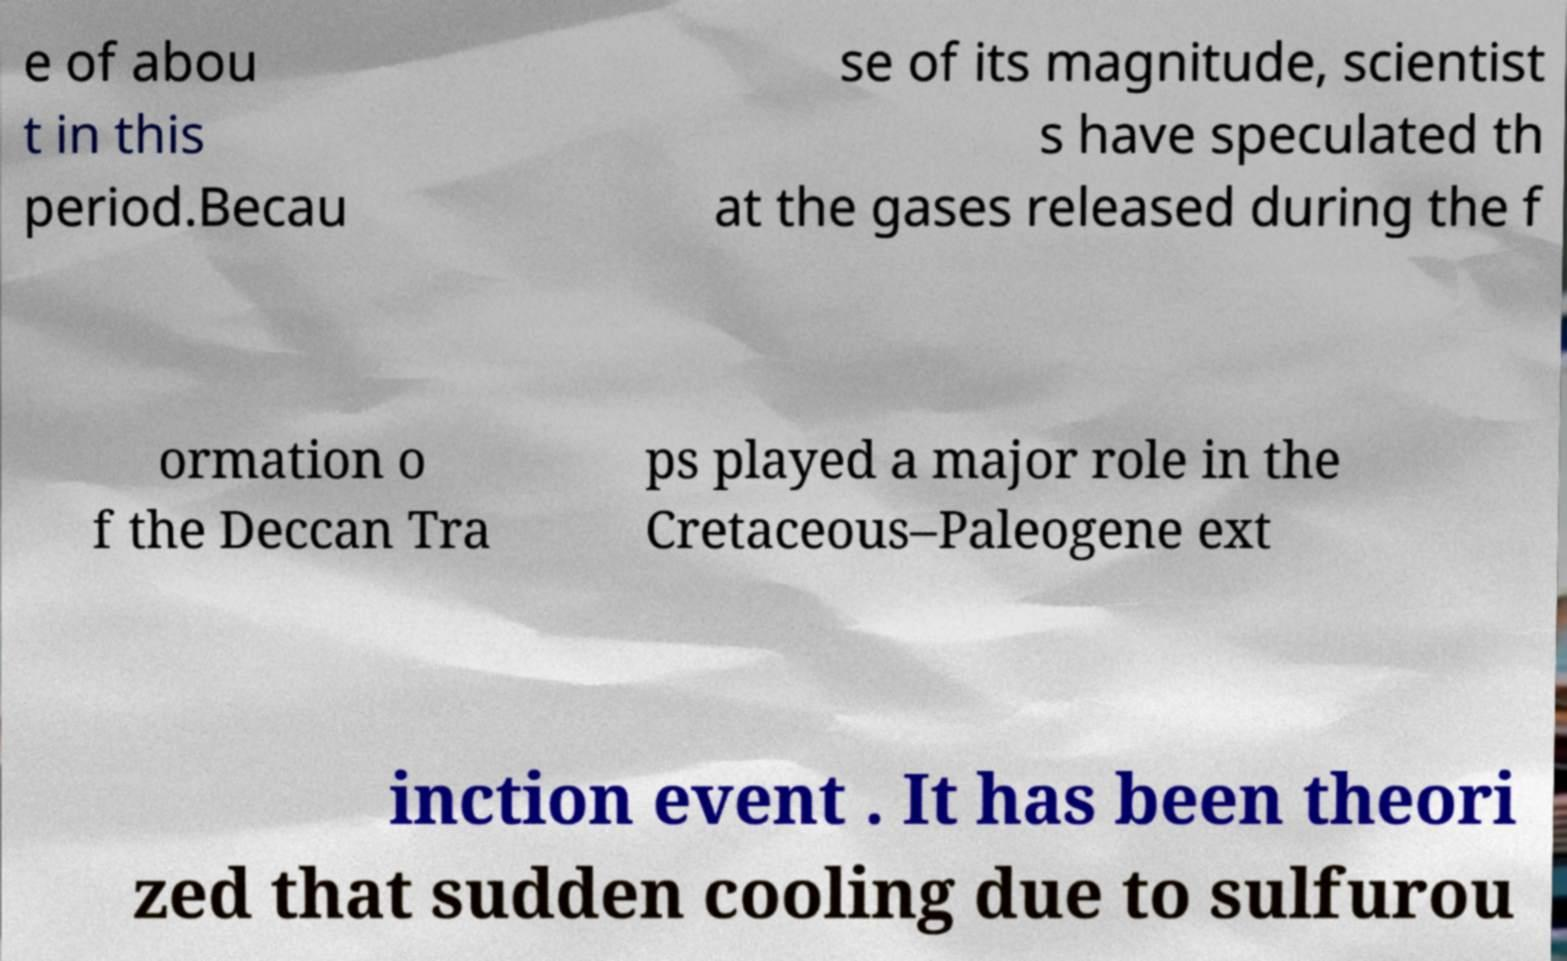Could you assist in decoding the text presented in this image and type it out clearly? e of abou t in this period.Becau se of its magnitude, scientist s have speculated th at the gases released during the f ormation o f the Deccan Tra ps played a major role in the Cretaceous–Paleogene ext inction event . It has been theori zed that sudden cooling due to sulfurou 